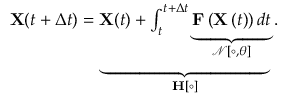Convert formula to latex. <formula><loc_0><loc_0><loc_500><loc_500>\begin{array} { r } { X ( t + \Delta t ) = \underbrace { X ( t ) + \int _ { t } ^ { t + \Delta t } \underbrace { F \left ( X \left ( t \right ) \right ) d t } _ { \mathcal { N [ \circ , \theta ] } } } _ { H [ \circ ] } . } \end{array}</formula> 